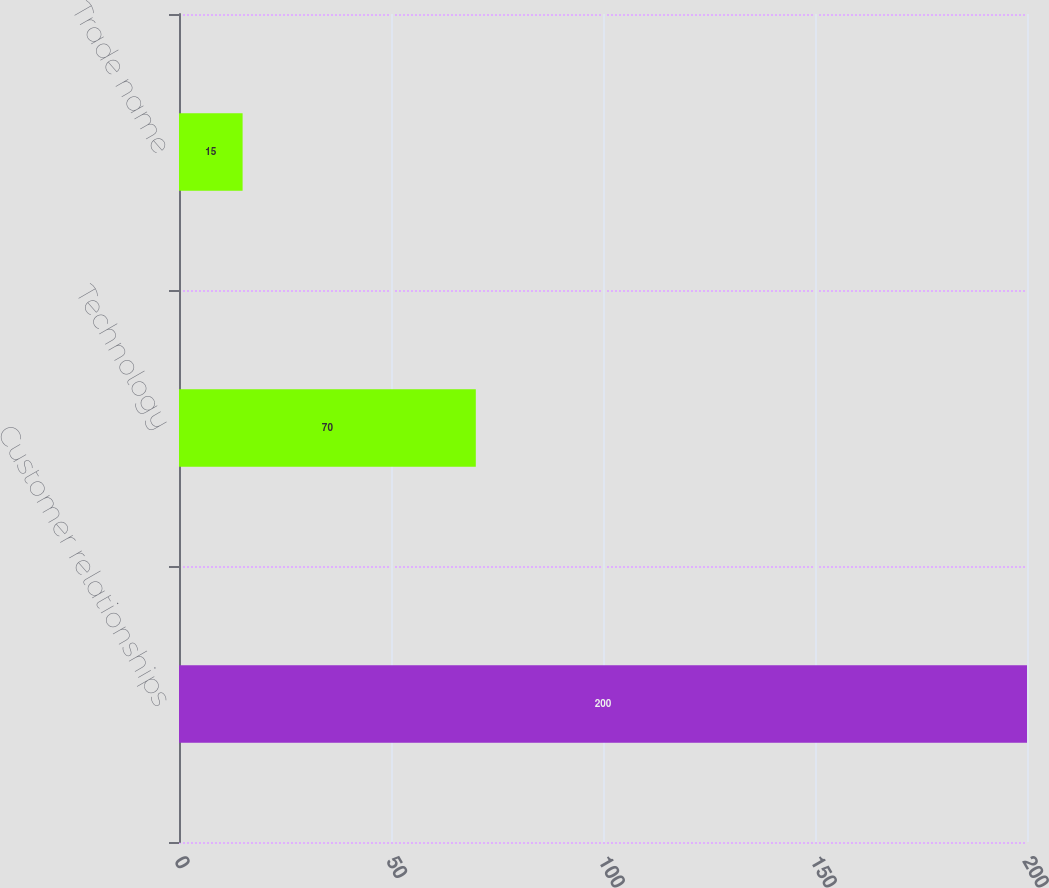Convert chart. <chart><loc_0><loc_0><loc_500><loc_500><bar_chart><fcel>Customer relationships<fcel>Technology<fcel>Trade name<nl><fcel>200<fcel>70<fcel>15<nl></chart> 